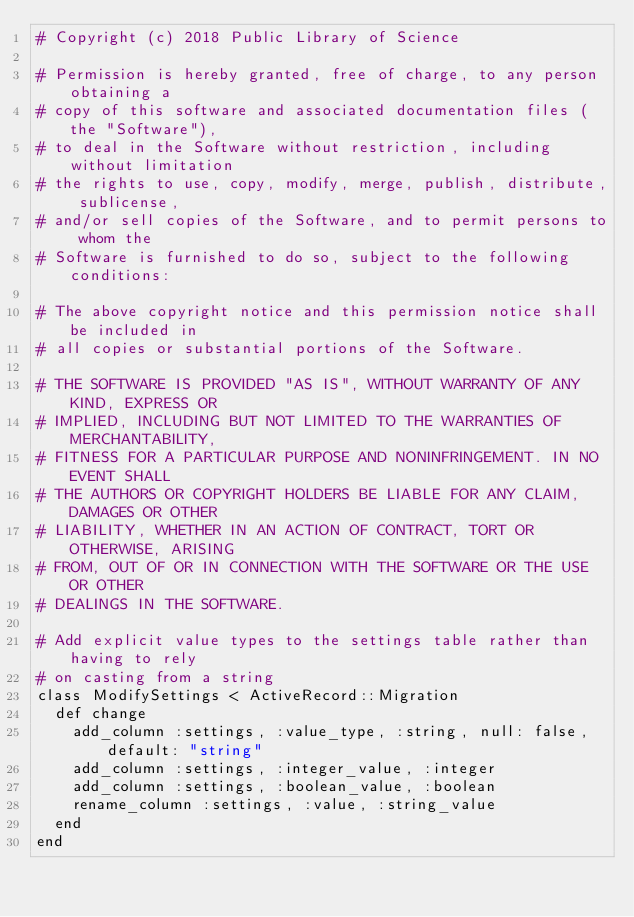<code> <loc_0><loc_0><loc_500><loc_500><_Ruby_># Copyright (c) 2018 Public Library of Science

# Permission is hereby granted, free of charge, to any person obtaining a
# copy of this software and associated documentation files (the "Software"),
# to deal in the Software without restriction, including without limitation
# the rights to use, copy, modify, merge, publish, distribute, sublicense,
# and/or sell copies of the Software, and to permit persons to whom the
# Software is furnished to do so, subject to the following conditions:

# The above copyright notice and this permission notice shall be included in
# all copies or substantial portions of the Software.

# THE SOFTWARE IS PROVIDED "AS IS", WITHOUT WARRANTY OF ANY KIND, EXPRESS OR
# IMPLIED, INCLUDING BUT NOT LIMITED TO THE WARRANTIES OF MERCHANTABILITY,
# FITNESS FOR A PARTICULAR PURPOSE AND NONINFRINGEMENT. IN NO EVENT SHALL
# THE AUTHORS OR COPYRIGHT HOLDERS BE LIABLE FOR ANY CLAIM, DAMAGES OR OTHER
# LIABILITY, WHETHER IN AN ACTION OF CONTRACT, TORT OR OTHERWISE, ARISING
# FROM, OUT OF OR IN CONNECTION WITH THE SOFTWARE OR THE USE OR OTHER
# DEALINGS IN THE SOFTWARE.

# Add explicit value types to the settings table rather than having to rely
# on casting from a string
class ModifySettings < ActiveRecord::Migration
  def change
    add_column :settings, :value_type, :string, null: false, default: "string"
    add_column :settings, :integer_value, :integer
    add_column :settings, :boolean_value, :boolean
    rename_column :settings, :value, :string_value
  end
end
</code> 